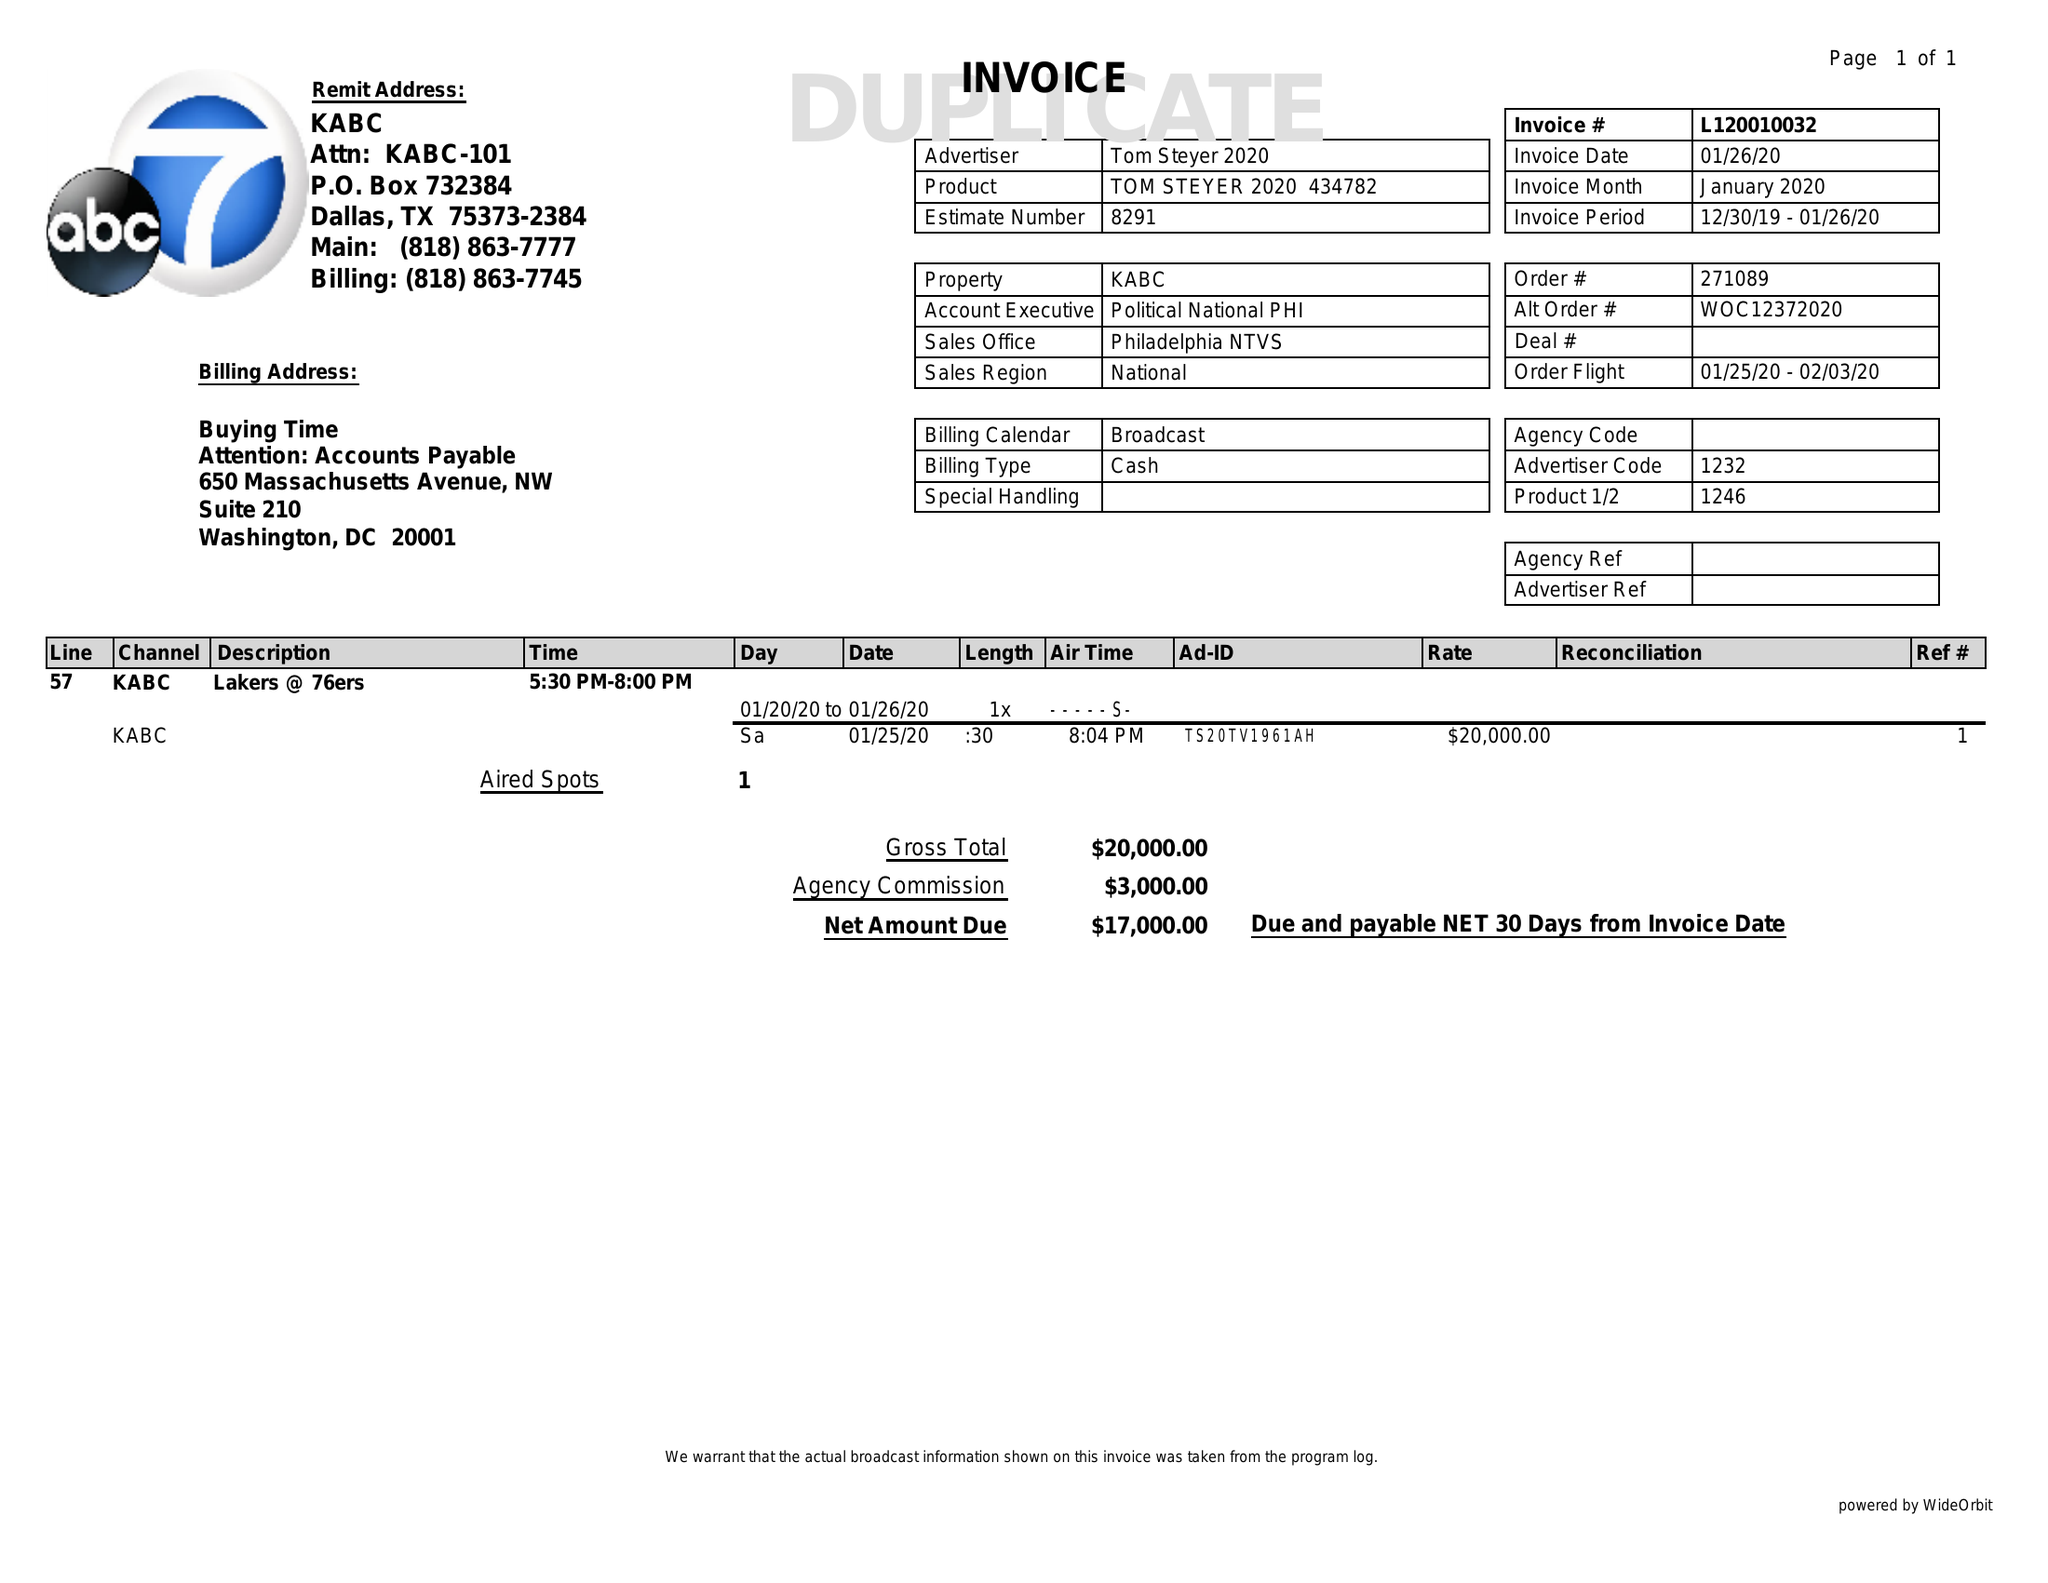What is the value for the gross_amount?
Answer the question using a single word or phrase. 20000.00 